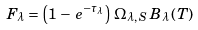<formula> <loc_0><loc_0><loc_500><loc_500>F _ { \lambda } = \left ( 1 \, - \, e ^ { - \tau _ { \lambda } } \right ) \, \Omega _ { \lambda , \, S } \, B _ { \lambda } \left ( T \right )</formula> 